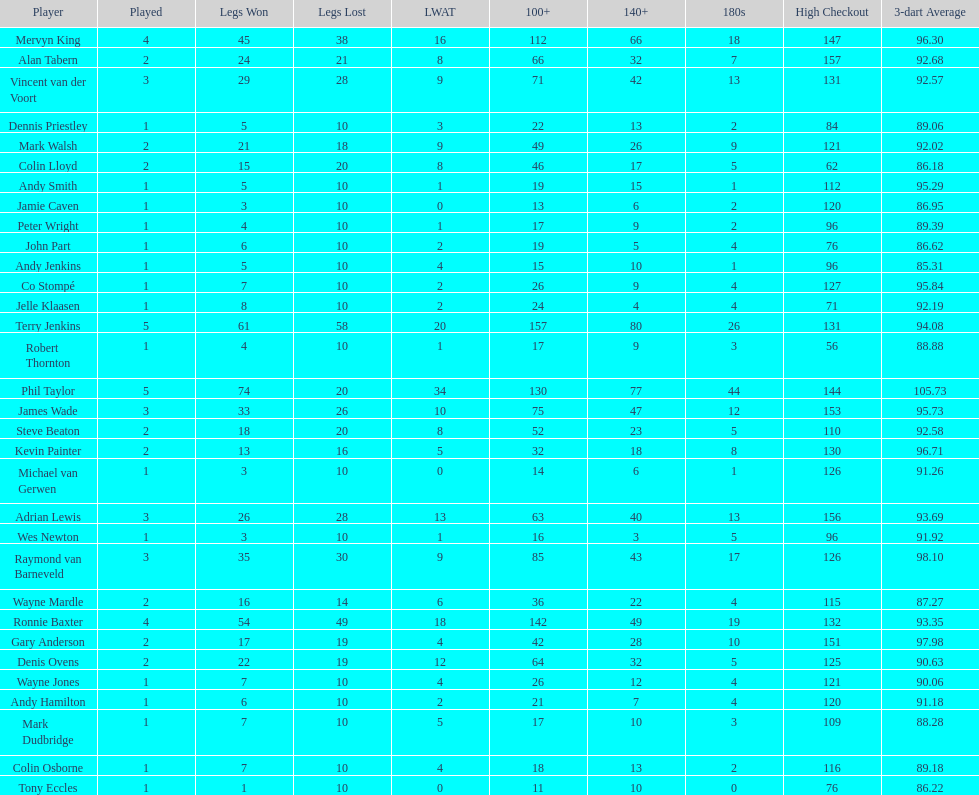Would you mind parsing the complete table? {'header': ['Player', 'Played', 'Legs Won', 'Legs Lost', 'LWAT', '100+', '140+', '180s', 'High Checkout', '3-dart Average'], 'rows': [['Mervyn King', '4', '45', '38', '16', '112', '66', '18', '147', '96.30'], ['Alan Tabern', '2', '24', '21', '8', '66', '32', '7', '157', '92.68'], ['Vincent van der Voort', '3', '29', '28', '9', '71', '42', '13', '131', '92.57'], ['Dennis Priestley', '1', '5', '10', '3', '22', '13', '2', '84', '89.06'], ['Mark Walsh', '2', '21', '18', '9', '49', '26', '9', '121', '92.02'], ['Colin Lloyd', '2', '15', '20', '8', '46', '17', '5', '62', '86.18'], ['Andy Smith', '1', '5', '10', '1', '19', '15', '1', '112', '95.29'], ['Jamie Caven', '1', '3', '10', '0', '13', '6', '2', '120', '86.95'], ['Peter Wright', '1', '4', '10', '1', '17', '9', '2', '96', '89.39'], ['John Part', '1', '6', '10', '2', '19', '5', '4', '76', '86.62'], ['Andy Jenkins', '1', '5', '10', '4', '15', '10', '1', '96', '85.31'], ['Co Stompé', '1', '7', '10', '2', '26', '9', '4', '127', '95.84'], ['Jelle Klaasen', '1', '8', '10', '2', '24', '4', '4', '71', '92.19'], ['Terry Jenkins', '5', '61', '58', '20', '157', '80', '26', '131', '94.08'], ['Robert Thornton', '1', '4', '10', '1', '17', '9', '3', '56', '88.88'], ['Phil Taylor', '5', '74', '20', '34', '130', '77', '44', '144', '105.73'], ['James Wade', '3', '33', '26', '10', '75', '47', '12', '153', '95.73'], ['Steve Beaton', '2', '18', '20', '8', '52', '23', '5', '110', '92.58'], ['Kevin Painter', '2', '13', '16', '5', '32', '18', '8', '130', '96.71'], ['Michael van Gerwen', '1', '3', '10', '0', '14', '6', '1', '126', '91.26'], ['Adrian Lewis', '3', '26', '28', '13', '63', '40', '13', '156', '93.69'], ['Wes Newton', '1', '3', '10', '1', '16', '3', '5', '96', '91.92'], ['Raymond van Barneveld', '3', '35', '30', '9', '85', '43', '17', '126', '98.10'], ['Wayne Mardle', '2', '16', '14', '6', '36', '22', '4', '115', '87.27'], ['Ronnie Baxter', '4', '54', '49', '18', '142', '49', '19', '132', '93.35'], ['Gary Anderson', '2', '17', '19', '4', '42', '28', '10', '151', '97.98'], ['Denis Ovens', '2', '22', '19', '12', '64', '32', '5', '125', '90.63'], ['Wayne Jones', '1', '7', '10', '4', '26', '12', '4', '121', '90.06'], ['Andy Hamilton', '1', '6', '10', '2', '21', '7', '4', '120', '91.18'], ['Mark Dudbridge', '1', '7', '10', '5', '17', '10', '3', '109', '88.28'], ['Colin Osborne', '1', '7', '10', '4', '18', '13', '2', '116', '89.18'], ['Tony Eccles', '1', '1', '10', '0', '11', '10', '0', '76', '86.22']]} Which player lost the least? Co Stompé, Andy Smith, Jelle Klaasen, Wes Newton, Michael van Gerwen, Andy Hamilton, Wayne Jones, Peter Wright, Colin Osborne, Dennis Priestley, Robert Thornton, Mark Dudbridge, Jamie Caven, John Part, Tony Eccles, Andy Jenkins. 